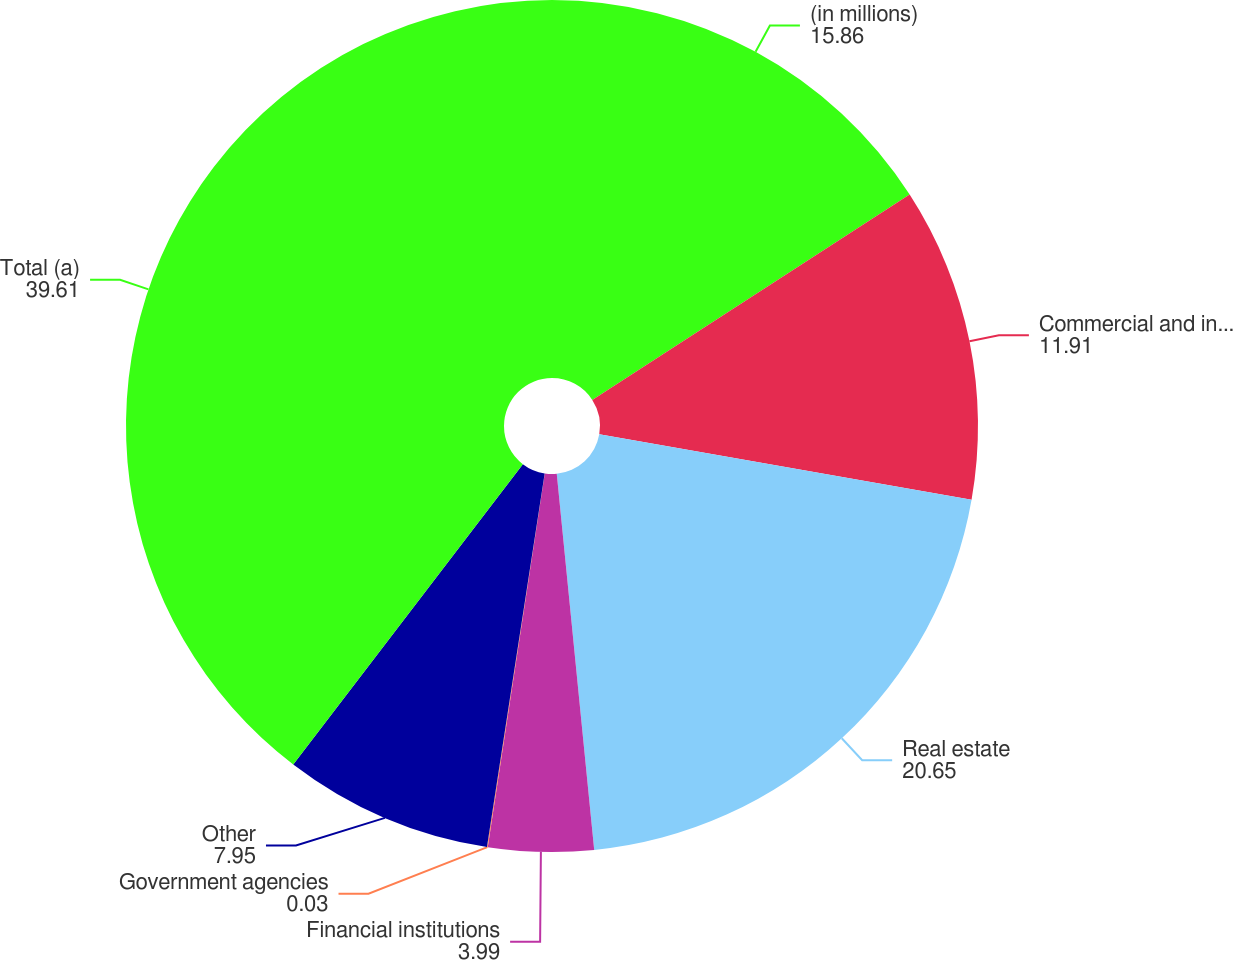Convert chart to OTSL. <chart><loc_0><loc_0><loc_500><loc_500><pie_chart><fcel>(in millions)<fcel>Commercial and industrial<fcel>Real estate<fcel>Financial institutions<fcel>Government agencies<fcel>Other<fcel>Total (a)<nl><fcel>15.86%<fcel>11.91%<fcel>20.65%<fcel>3.99%<fcel>0.03%<fcel>7.95%<fcel>39.61%<nl></chart> 